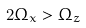Convert formula to latex. <formula><loc_0><loc_0><loc_500><loc_500>2 \Omega _ { x } > \Omega _ { z }</formula> 